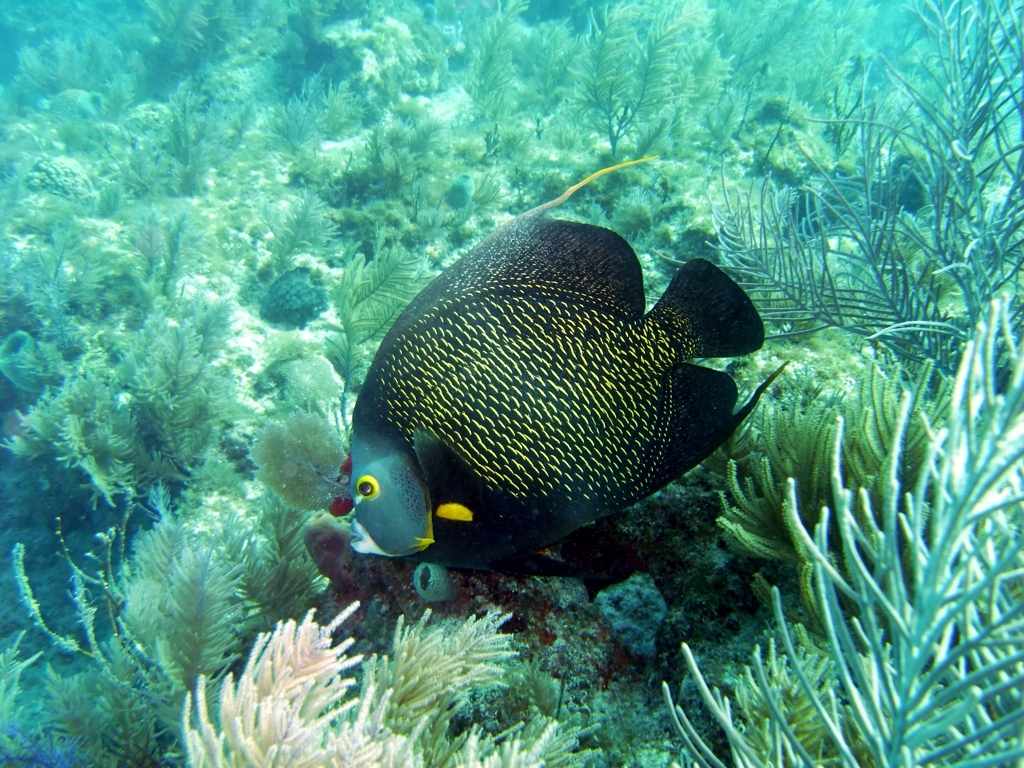Describe the environment shown in the image. The underwater environment depicted in the image is a vibrant and healthy coral reef ecosystem. It showcases a diversity of species and a thriving aquatic plant life. The corals appear to be in good condition, which suggests the water quality is optimum, supporting a rich marine biodiversity. Why is this type of environment important? Coral reefs are incredibly important for ecological balance in the ocean. They provide habitat and breeding grounds for numerous marine species, help protect coastlines from storms and erosion, and offer benefits for humans such as fishing resources and opportunities for ecotourism. They are also critical for global biodiversity and help to sustain ocean health. 